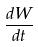<formula> <loc_0><loc_0><loc_500><loc_500>\frac { d W } { d t }</formula> 